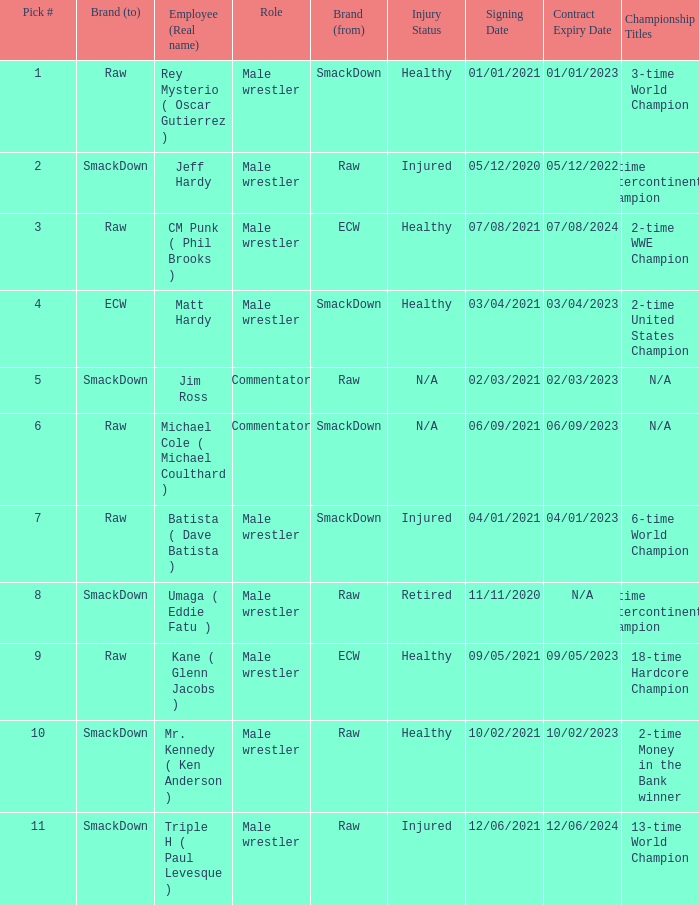Parse the full table. {'header': ['Pick #', 'Brand (to)', 'Employee (Real name)', 'Role', 'Brand (from)', 'Injury Status', 'Signing Date', 'Contract Expiry Date', 'Championship Titles'], 'rows': [['1', 'Raw', 'Rey Mysterio ( Oscar Gutierrez )', 'Male wrestler', 'SmackDown', 'Healthy', '01/01/2021', '01/01/2023', '3-time World Champion'], ['2', 'SmackDown', 'Jeff Hardy', 'Male wrestler', 'Raw', 'Injured', '05/12/2020', '05/12/2022', '4-time Intercontinental Champion'], ['3', 'Raw', 'CM Punk ( Phil Brooks )', 'Male wrestler', 'ECW', 'Healthy', '07/08/2021', '07/08/2024', '2-time WWE Champion'], ['4', 'ECW', 'Matt Hardy', 'Male wrestler', 'SmackDown', 'Healthy', '03/04/2021', '03/04/2023', '2-time United States Champion'], ['5', 'SmackDown', 'Jim Ross', 'Commentator', 'Raw', 'N/A', '02/03/2021', '02/03/2023', 'N/A'], ['6', 'Raw', 'Michael Cole ( Michael Coulthard )', 'Commentator', 'SmackDown', 'N/A', '06/09/2021', '06/09/2023', 'N/A'], ['7', 'Raw', 'Batista ( Dave Batista )', 'Male wrestler', 'SmackDown', 'Injured', '04/01/2021', '04/01/2023', '6-time World Champion'], ['8', 'SmackDown', 'Umaga ( Eddie Fatu )', 'Male wrestler', 'Raw', 'Retired', '11/11/2020', 'N/A', '2-time Intercontinental Champion'], ['9', 'Raw', 'Kane ( Glenn Jacobs )', 'Male wrestler', 'ECW', 'Healthy', '09/05/2021', '09/05/2023', '18-time Hardcore Champion '], ['10', 'SmackDown', 'Mr. Kennedy ( Ken Anderson )', 'Male wrestler', 'Raw', 'Healthy', '10/02/2021', '10/02/2023', '2-time Money in the Bank winner'], ['11', 'SmackDown', 'Triple H ( Paul Levesque )', 'Male wrestler', 'Raw', 'Injured', '12/06/2021', '12/06/2024', '13-time World Champion']]} What role did Pick # 10 have? Male wrestler. 